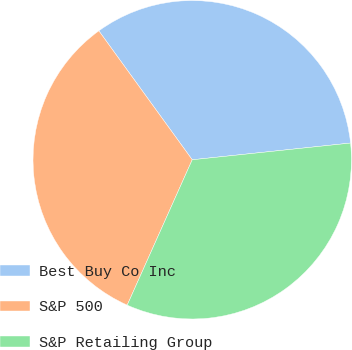Convert chart to OTSL. <chart><loc_0><loc_0><loc_500><loc_500><pie_chart><fcel>Best Buy Co Inc<fcel>S&P 500<fcel>S&P Retailing Group<nl><fcel>33.3%<fcel>33.33%<fcel>33.37%<nl></chart> 